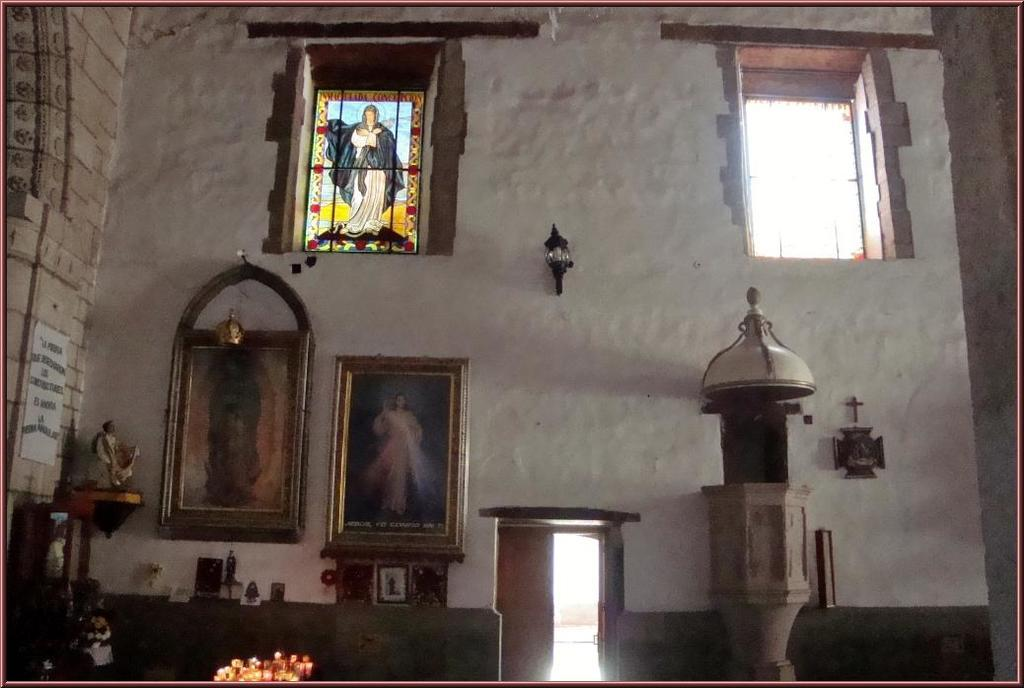What type of location might the image be taken in? The image might be taken in a church. What architectural features can be seen in the image? There are doors and windows in the image. What decorative elements are present in the image? There are photo frames in the image. What is the source of light in the image? There is light in the image. What type of structure is visible in the image? There is a wall in the image. What type of statue can be seen in the image? There is a statue in the image. What type of locket is hanging from the statue's neck in the image? There is no locket present on the statue in the image. How does the bomb affect the church in the image? There is no bomb present in the image, so it cannot affect the church. 